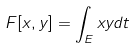Convert formula to latex. <formula><loc_0><loc_0><loc_500><loc_500>F [ x , y ] = \int _ { E } x y d t</formula> 